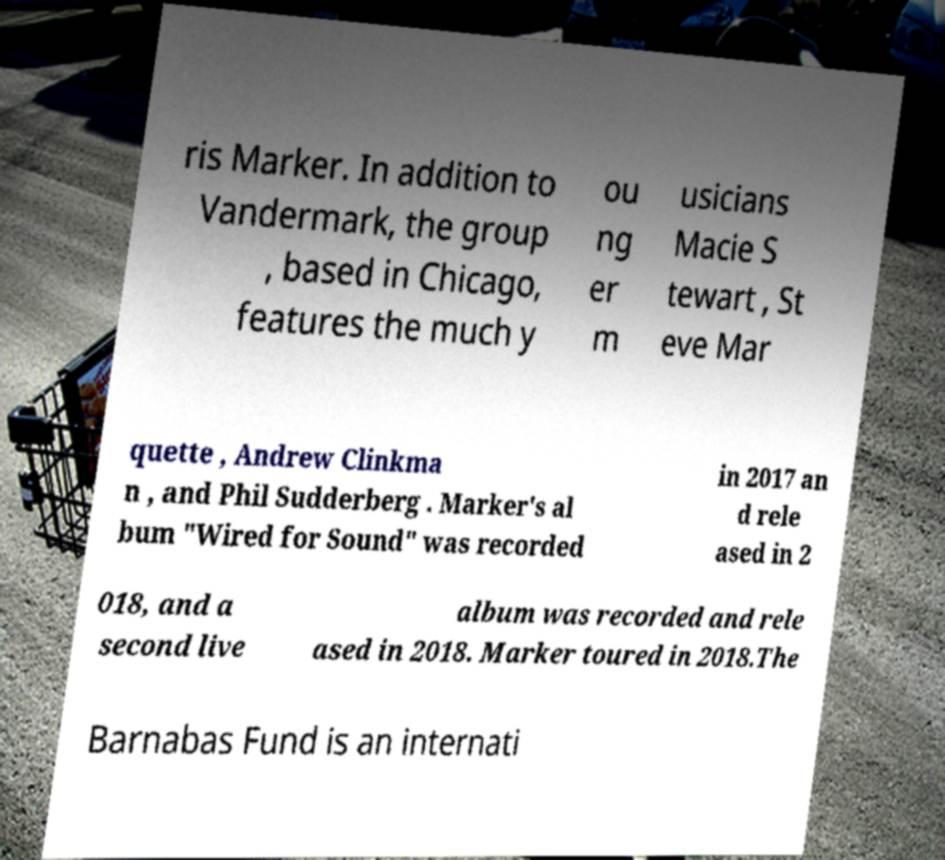I need the written content from this picture converted into text. Can you do that? ris Marker. In addition to Vandermark, the group , based in Chicago, features the much y ou ng er m usicians Macie S tewart , St eve Mar quette , Andrew Clinkma n , and Phil Sudderberg . Marker's al bum "Wired for Sound" was recorded in 2017 an d rele ased in 2 018, and a second live album was recorded and rele ased in 2018. Marker toured in 2018.The Barnabas Fund is an internati 